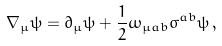<formula> <loc_0><loc_0><loc_500><loc_500>\nabla _ { \mu } \psi = \partial _ { \mu } \psi + \frac { 1 } { 2 } \omega _ { \mu a b } \sigma ^ { a b } \psi \, ,</formula> 